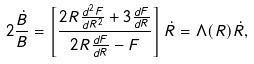<formula> <loc_0><loc_0><loc_500><loc_500>2 \frac { \dot { B } } { B } = \left [ \frac { 2 R \frac { d ^ { 2 } F } { d R ^ { 2 } } + 3 \frac { d F } { d R } } { 2 R \frac { d F } { d R } - F } \right ] \dot { R } = \Lambda ( R ) \dot { R } ,</formula> 